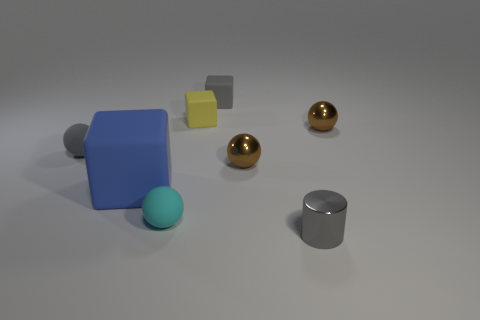How many other objects are there of the same shape as the yellow object?
Give a very brief answer. 2. Do the blue matte thing and the small gray shiny object have the same shape?
Ensure brevity in your answer.  No. Are there any blocks on the right side of the yellow rubber block?
Offer a very short reply. Yes. How many objects are either tiny green matte things or tiny blocks?
Your response must be concise. 2. How many other objects are the same size as the blue rubber thing?
Your answer should be compact. 0. What number of small objects are both in front of the small yellow thing and on the left side of the tiny gray cylinder?
Ensure brevity in your answer.  3. Does the brown object on the right side of the shiny cylinder have the same size as the object that is on the left side of the blue thing?
Provide a short and direct response. Yes. What size is the thing that is behind the tiny yellow thing?
Provide a succinct answer. Small. What number of objects are balls that are left of the big matte block or rubber things right of the blue cube?
Keep it short and to the point. 4. Are there any other things of the same color as the large matte block?
Make the answer very short. No. 